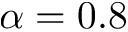<formula> <loc_0><loc_0><loc_500><loc_500>\alpha = 0 . 8</formula> 